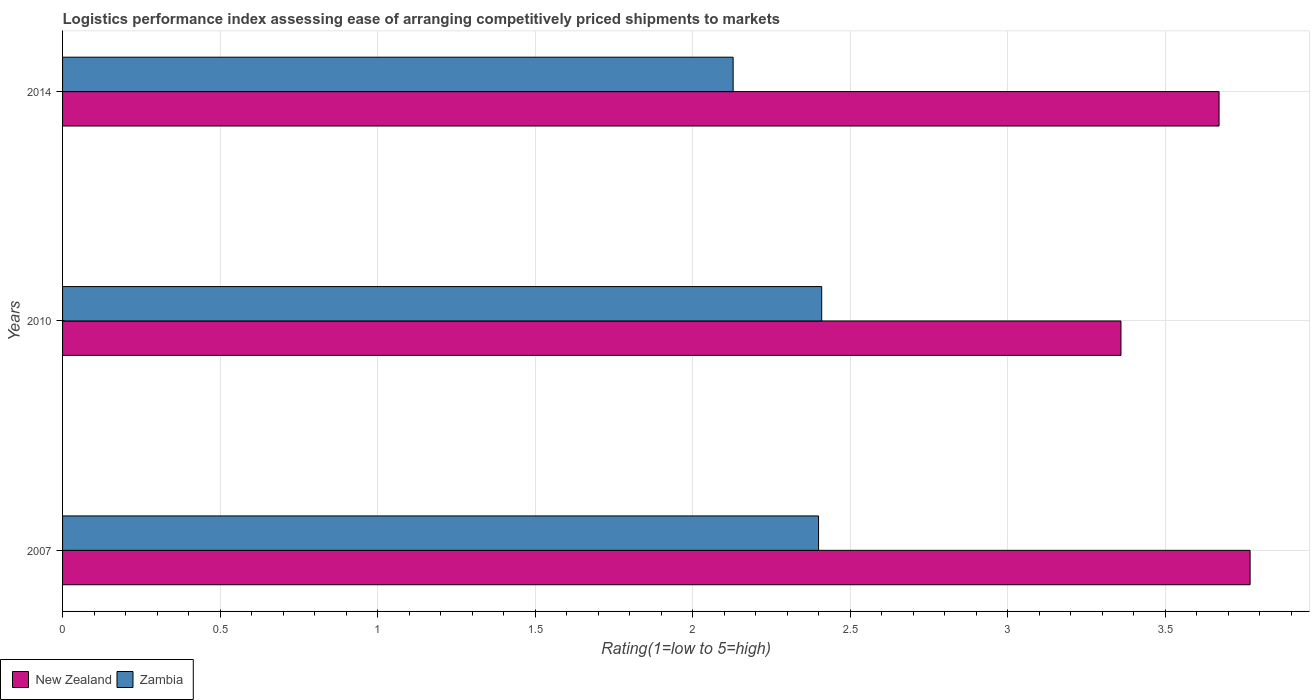How many different coloured bars are there?
Offer a terse response. 2. Are the number of bars per tick equal to the number of legend labels?
Ensure brevity in your answer.  Yes. Are the number of bars on each tick of the Y-axis equal?
Make the answer very short. Yes. In how many cases, is the number of bars for a given year not equal to the number of legend labels?
Your answer should be compact. 0. What is the Logistic performance index in New Zealand in 2010?
Make the answer very short. 3.36. Across all years, what is the maximum Logistic performance index in New Zealand?
Offer a very short reply. 3.77. Across all years, what is the minimum Logistic performance index in Zambia?
Make the answer very short. 2.13. In which year was the Logistic performance index in Zambia minimum?
Your answer should be very brief. 2014. What is the total Logistic performance index in New Zealand in the graph?
Your response must be concise. 10.8. What is the difference between the Logistic performance index in New Zealand in 2007 and that in 2014?
Provide a succinct answer. 0.1. What is the difference between the Logistic performance index in Zambia in 2010 and the Logistic performance index in New Zealand in 2014?
Your answer should be very brief. -1.26. What is the average Logistic performance index in Zambia per year?
Make the answer very short. 2.31. In the year 2007, what is the difference between the Logistic performance index in New Zealand and Logistic performance index in Zambia?
Your response must be concise. 1.37. What is the ratio of the Logistic performance index in New Zealand in 2007 to that in 2014?
Your answer should be compact. 1.03. Is the Logistic performance index in Zambia in 2007 less than that in 2014?
Offer a very short reply. No. Is the difference between the Logistic performance index in New Zealand in 2007 and 2014 greater than the difference between the Logistic performance index in Zambia in 2007 and 2014?
Provide a succinct answer. No. What is the difference between the highest and the second highest Logistic performance index in New Zealand?
Your response must be concise. 0.1. What is the difference between the highest and the lowest Logistic performance index in Zambia?
Keep it short and to the point. 0.28. What does the 2nd bar from the top in 2010 represents?
Give a very brief answer. New Zealand. What does the 2nd bar from the bottom in 2007 represents?
Your response must be concise. Zambia. How many bars are there?
Your answer should be very brief. 6. Are all the bars in the graph horizontal?
Your response must be concise. Yes. Are the values on the major ticks of X-axis written in scientific E-notation?
Make the answer very short. No. Does the graph contain any zero values?
Provide a succinct answer. No. Does the graph contain grids?
Give a very brief answer. Yes. How many legend labels are there?
Offer a very short reply. 2. How are the legend labels stacked?
Give a very brief answer. Horizontal. What is the title of the graph?
Your response must be concise. Logistics performance index assessing ease of arranging competitively priced shipments to markets. What is the label or title of the X-axis?
Provide a short and direct response. Rating(1=low to 5=high). What is the label or title of the Y-axis?
Make the answer very short. Years. What is the Rating(1=low to 5=high) of New Zealand in 2007?
Give a very brief answer. 3.77. What is the Rating(1=low to 5=high) of New Zealand in 2010?
Offer a very short reply. 3.36. What is the Rating(1=low to 5=high) in Zambia in 2010?
Your answer should be very brief. 2.41. What is the Rating(1=low to 5=high) of New Zealand in 2014?
Make the answer very short. 3.67. What is the Rating(1=low to 5=high) of Zambia in 2014?
Your response must be concise. 2.13. Across all years, what is the maximum Rating(1=low to 5=high) in New Zealand?
Ensure brevity in your answer.  3.77. Across all years, what is the maximum Rating(1=low to 5=high) of Zambia?
Provide a succinct answer. 2.41. Across all years, what is the minimum Rating(1=low to 5=high) in New Zealand?
Offer a very short reply. 3.36. Across all years, what is the minimum Rating(1=low to 5=high) of Zambia?
Offer a very short reply. 2.13. What is the total Rating(1=low to 5=high) in New Zealand in the graph?
Offer a very short reply. 10.8. What is the total Rating(1=low to 5=high) in Zambia in the graph?
Give a very brief answer. 6.94. What is the difference between the Rating(1=low to 5=high) of New Zealand in 2007 and that in 2010?
Make the answer very short. 0.41. What is the difference between the Rating(1=low to 5=high) in Zambia in 2007 and that in 2010?
Offer a very short reply. -0.01. What is the difference between the Rating(1=low to 5=high) in New Zealand in 2007 and that in 2014?
Provide a short and direct response. 0.1. What is the difference between the Rating(1=low to 5=high) of Zambia in 2007 and that in 2014?
Ensure brevity in your answer.  0.27. What is the difference between the Rating(1=low to 5=high) of New Zealand in 2010 and that in 2014?
Ensure brevity in your answer.  -0.31. What is the difference between the Rating(1=low to 5=high) in Zambia in 2010 and that in 2014?
Your response must be concise. 0.28. What is the difference between the Rating(1=low to 5=high) in New Zealand in 2007 and the Rating(1=low to 5=high) in Zambia in 2010?
Keep it short and to the point. 1.36. What is the difference between the Rating(1=low to 5=high) of New Zealand in 2007 and the Rating(1=low to 5=high) of Zambia in 2014?
Make the answer very short. 1.64. What is the difference between the Rating(1=low to 5=high) in New Zealand in 2010 and the Rating(1=low to 5=high) in Zambia in 2014?
Ensure brevity in your answer.  1.23. What is the average Rating(1=low to 5=high) of New Zealand per year?
Provide a succinct answer. 3.6. What is the average Rating(1=low to 5=high) in Zambia per year?
Give a very brief answer. 2.31. In the year 2007, what is the difference between the Rating(1=low to 5=high) in New Zealand and Rating(1=low to 5=high) in Zambia?
Your answer should be very brief. 1.37. In the year 2010, what is the difference between the Rating(1=low to 5=high) of New Zealand and Rating(1=low to 5=high) of Zambia?
Provide a short and direct response. 0.95. In the year 2014, what is the difference between the Rating(1=low to 5=high) of New Zealand and Rating(1=low to 5=high) of Zambia?
Make the answer very short. 1.54. What is the ratio of the Rating(1=low to 5=high) in New Zealand in 2007 to that in 2010?
Make the answer very short. 1.12. What is the ratio of the Rating(1=low to 5=high) of New Zealand in 2007 to that in 2014?
Your answer should be very brief. 1.03. What is the ratio of the Rating(1=low to 5=high) in Zambia in 2007 to that in 2014?
Ensure brevity in your answer.  1.13. What is the ratio of the Rating(1=low to 5=high) in New Zealand in 2010 to that in 2014?
Your response must be concise. 0.92. What is the ratio of the Rating(1=low to 5=high) of Zambia in 2010 to that in 2014?
Offer a very short reply. 1.13. What is the difference between the highest and the second highest Rating(1=low to 5=high) of New Zealand?
Make the answer very short. 0.1. What is the difference between the highest and the second highest Rating(1=low to 5=high) of Zambia?
Your answer should be compact. 0.01. What is the difference between the highest and the lowest Rating(1=low to 5=high) of New Zealand?
Offer a very short reply. 0.41. What is the difference between the highest and the lowest Rating(1=low to 5=high) of Zambia?
Your response must be concise. 0.28. 